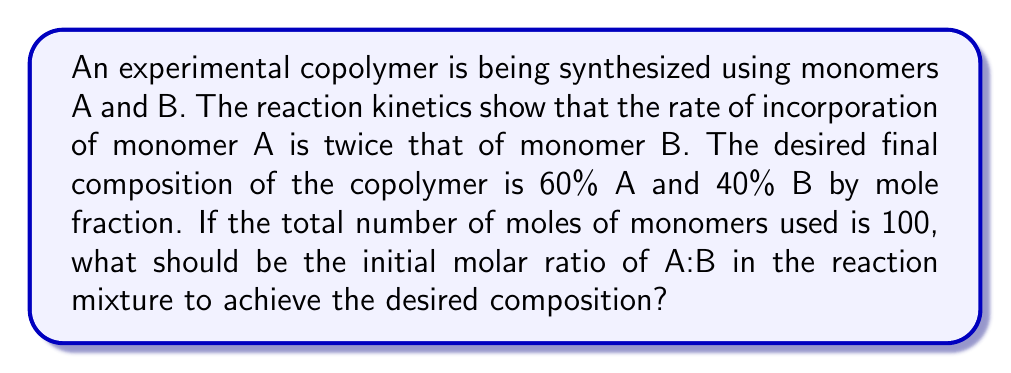Can you answer this question? Let's approach this step-by-step:

1) Let $x$ be the number of moles of monomer A in the initial mixture.
   Then, $(100-x)$ will be the number of moles of monomer B.

2) Given that the rate of incorporation of A is twice that of B, we can set up the equation:
   $$\frac{2x}{2x + (100-x)} = 0.60$$

3) This equation represents the final mole fraction of A in the copolymer.

4) Simplify the denominator:
   $$\frac{2x}{100+x} = 0.60$$

5) Multiply both sides by $(100+x)$:
   $$2x = 0.60(100+x)$$

6) Distribute on the right side:
   $$2x = 60 + 0.60x$$

7) Subtract $0.60x$ from both sides:
   $$1.40x = 60$$

8) Divide both sides by 1.40:
   $$x = \frac{60}{1.40} \approx 42.86$$

9) Therefore, the initial mixture should contain approximately 42.86 moles of A and 57.14 moles of B.

10) The ratio A:B is thus 42.86 : 57.14, which simplifies to 3 : 4.
Answer: 3:4 